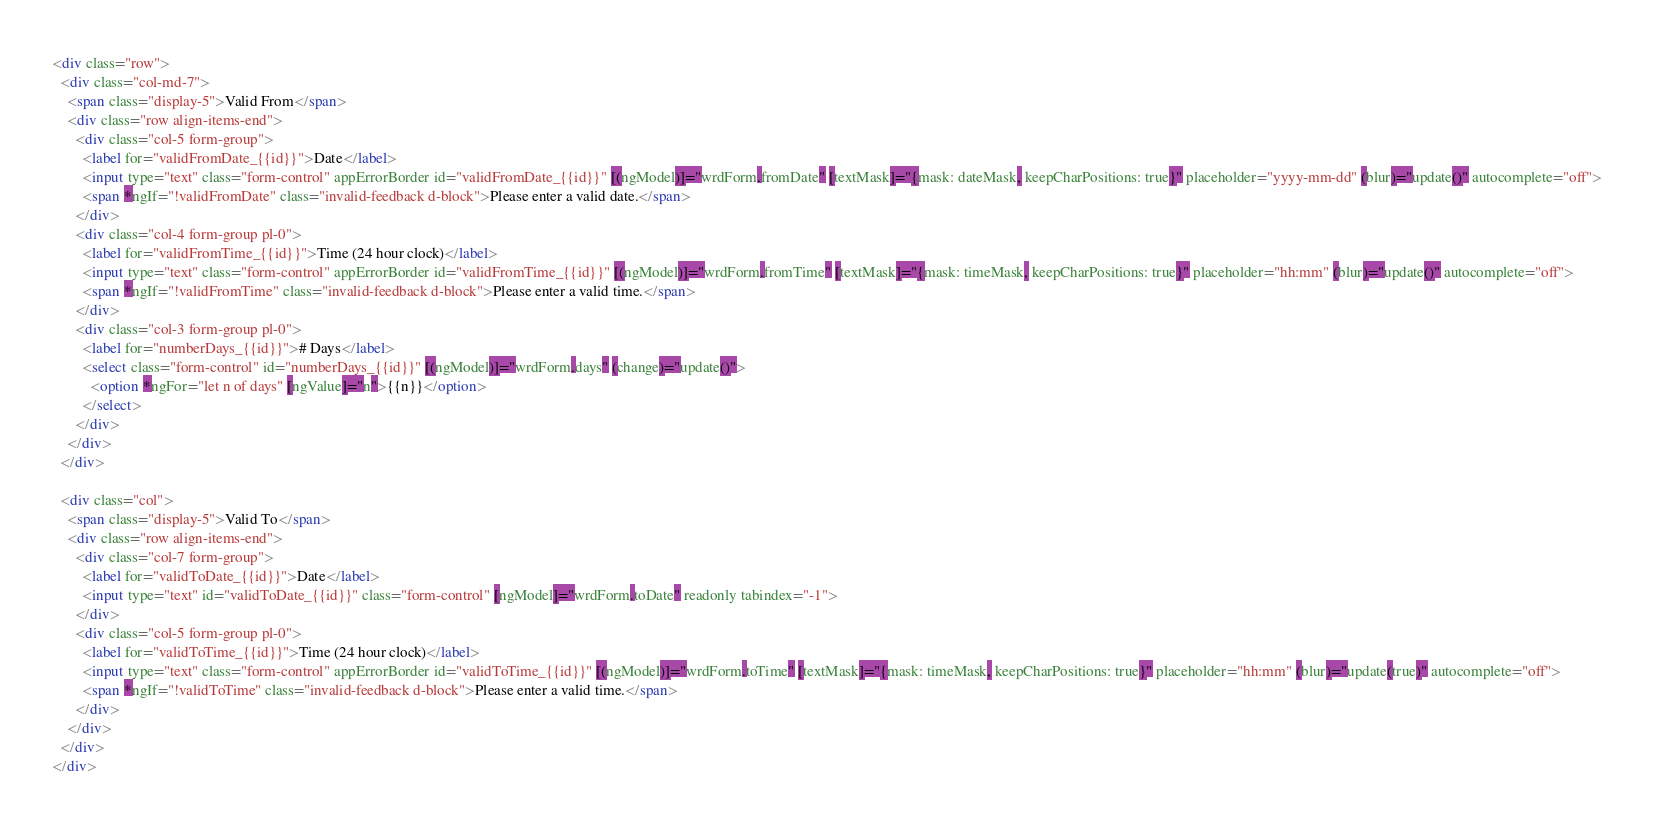<code> <loc_0><loc_0><loc_500><loc_500><_HTML_><div class="row">
  <div class="col-md-7">
    <span class="display-5">Valid From</span>
    <div class="row align-items-end">
      <div class="col-5 form-group">
        <label for="validFromDate_{{id}}">Date</label>
        <input type="text" class="form-control" appErrorBorder id="validFromDate_{{id}}" [(ngModel)]="wrdForm.fromDate" [textMask]="{mask: dateMask, keepCharPositions: true}" placeholder="yyyy-mm-dd" (blur)="update()" autocomplete="off">
        <span *ngIf="!validFromDate" class="invalid-feedback d-block">Please enter a valid date.</span>
      </div>
      <div class="col-4 form-group pl-0">
        <label for="validFromTime_{{id}}">Time (24 hour clock)</label>
        <input type="text" class="form-control" appErrorBorder id="validFromTime_{{id}}" [(ngModel)]="wrdForm.fromTime" [textMask]="{mask: timeMask, keepCharPositions: true}" placeholder="hh:mm" (blur)="update()" autocomplete="off">
        <span *ngIf="!validFromTime" class="invalid-feedback d-block">Please enter a valid time.</span>
      </div>
      <div class="col-3 form-group pl-0">
        <label for="numberDays_{{id}}"># Days</label>
        <select class="form-control" id="numberDays_{{id}}" [(ngModel)]="wrdForm.days" (change)="update()">
          <option *ngFor="let n of days" [ngValue]="n">{{n}}</option>
        </select>
      </div>
    </div>
  </div>

  <div class="col">
    <span class="display-5">Valid To</span>
    <div class="row align-items-end">
      <div class="col-7 form-group">
        <label for="validToDate_{{id}}">Date</label>
        <input type="text" id="validToDate_{{id}}" class="form-control" [ngModel]="wrdForm.toDate" readonly tabindex="-1">
      </div>
      <div class="col-5 form-group pl-0">
        <label for="validToTime_{{id}}">Time (24 hour clock)</label>
        <input type="text" class="form-control" appErrorBorder id="validToTime_{{id}}" [(ngModel)]="wrdForm.toTime" [textMask]="{mask: timeMask, keepCharPositions: true}" placeholder="hh:mm" (blur)="update(true)" autocomplete="off">
        <span *ngIf="!validToTime" class="invalid-feedback d-block">Please enter a valid time.</span>
      </div>
    </div>
  </div>
</div>
</code> 